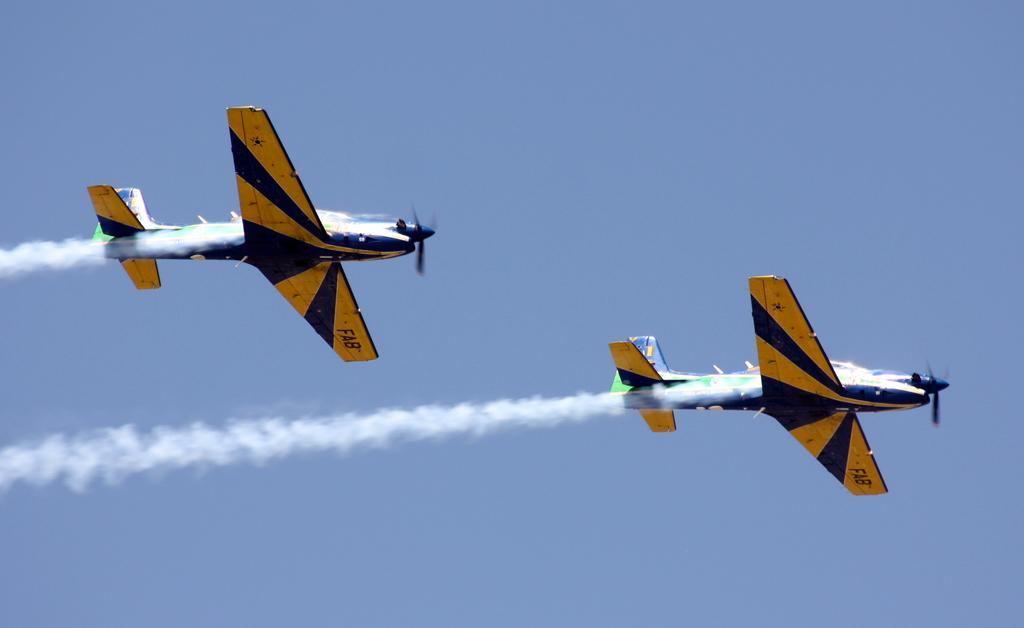How many airplanes are visible in the image? There are two airplanes in the image. What are the airplanes doing in the image? The airplanes are flying in the air. What can be seen behind the airplanes as they fly? The airplanes are leaving smoke behind them. Where is the throne located in the image? There is no throne present in the image. Is the snow visible in the image? There is no snow visible in the image. 